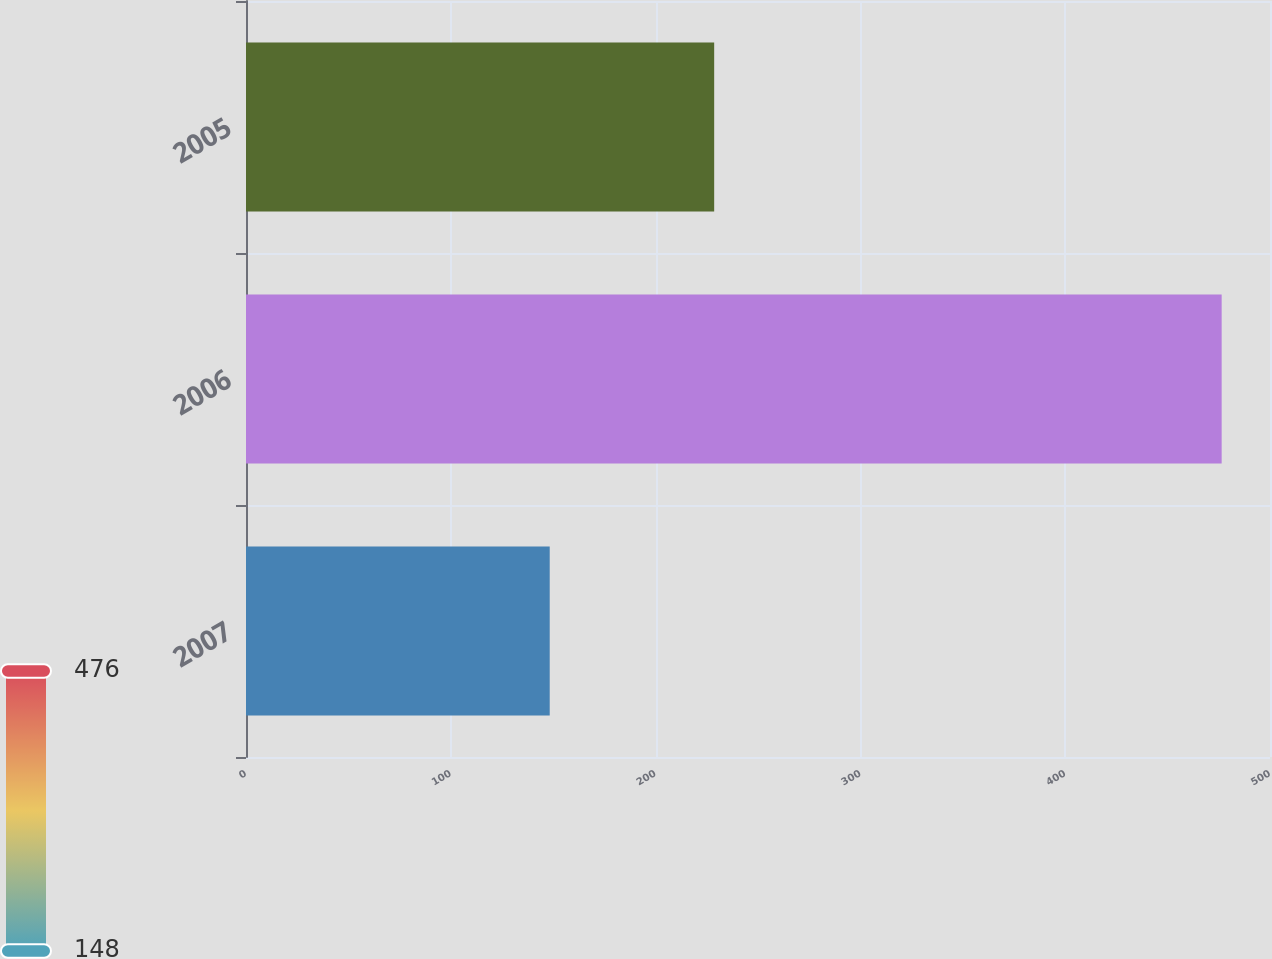<chart> <loc_0><loc_0><loc_500><loc_500><bar_chart><fcel>2007<fcel>2006<fcel>2005<nl><fcel>148.3<fcel>476.4<fcel>228.6<nl></chart> 